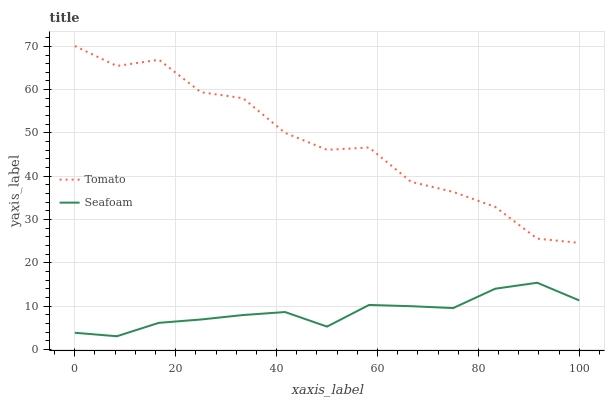Does Seafoam have the maximum area under the curve?
Answer yes or no. No. Is Seafoam the roughest?
Answer yes or no. No. Does Seafoam have the highest value?
Answer yes or no. No. Is Seafoam less than Tomato?
Answer yes or no. Yes. Is Tomato greater than Seafoam?
Answer yes or no. Yes. Does Seafoam intersect Tomato?
Answer yes or no. No. 